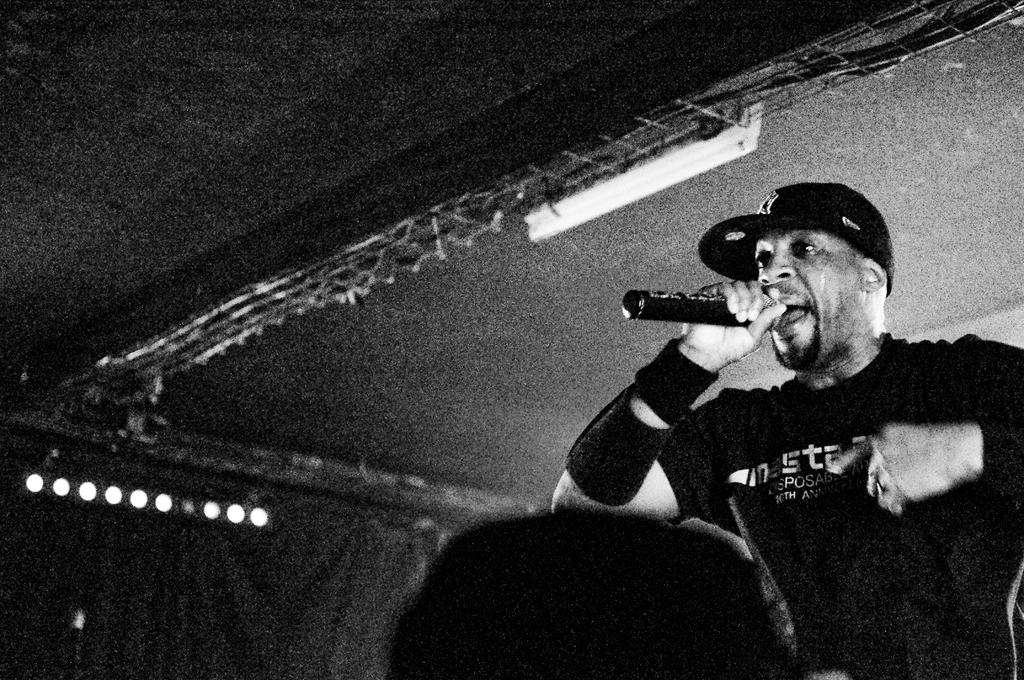What is the man in the image doing? The man is singing in the image. What tool is the man using to amplify his voice? The man is using a microphone in the image. What can be seen in the background of the image? There are metal rods and lights in the background of the image. What type of locket is the man wearing around his neck in the image? There is no locket visible around the man's neck in the image. 